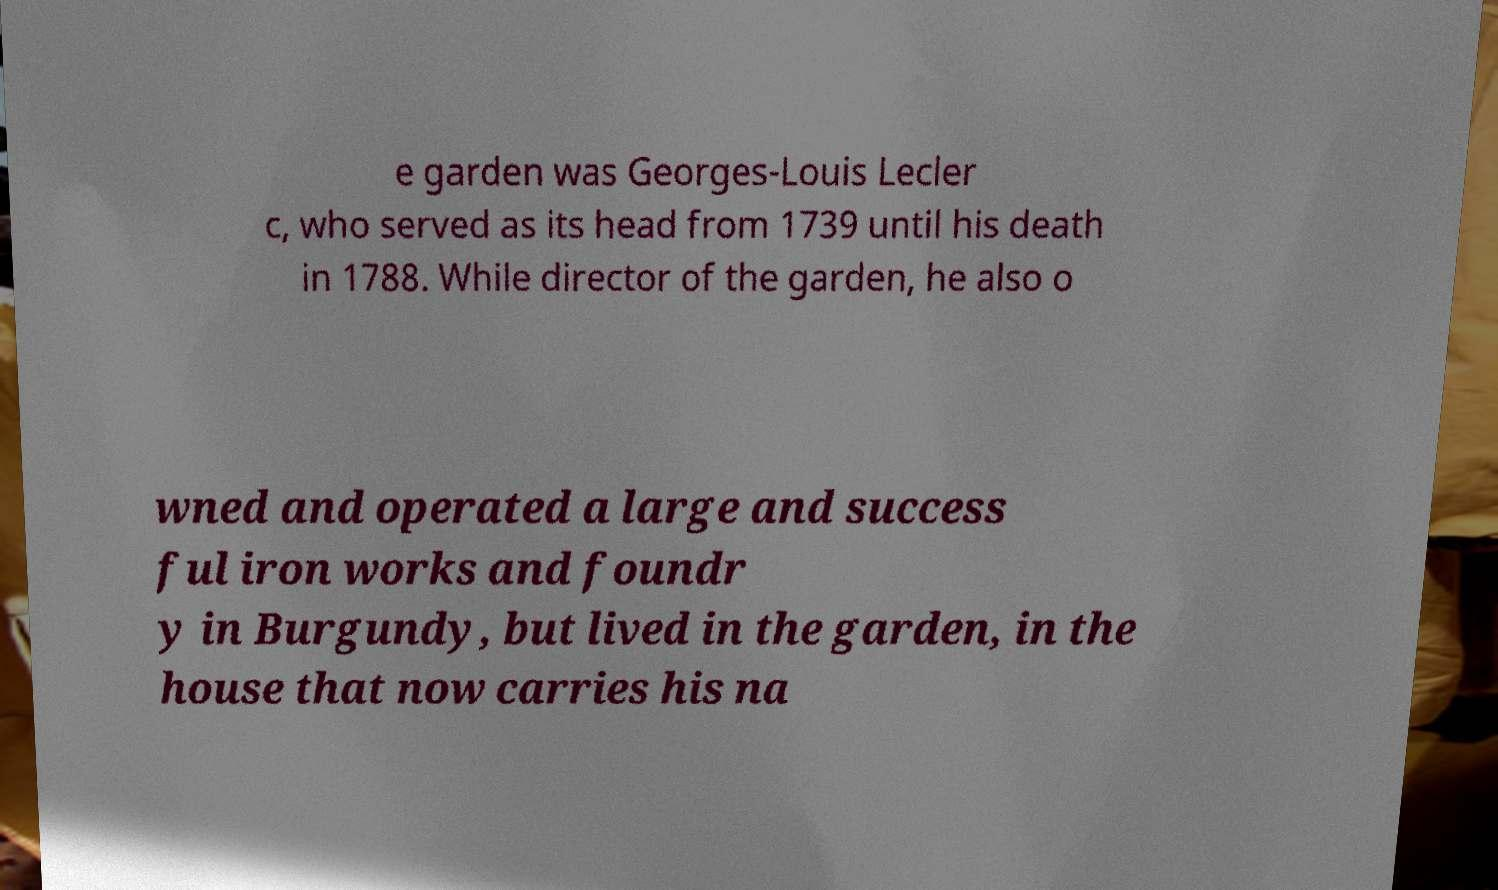Can you accurately transcribe the text from the provided image for me? e garden was Georges-Louis Lecler c, who served as its head from 1739 until his death in 1788. While director of the garden, he also o wned and operated a large and success ful iron works and foundr y in Burgundy, but lived in the garden, in the house that now carries his na 